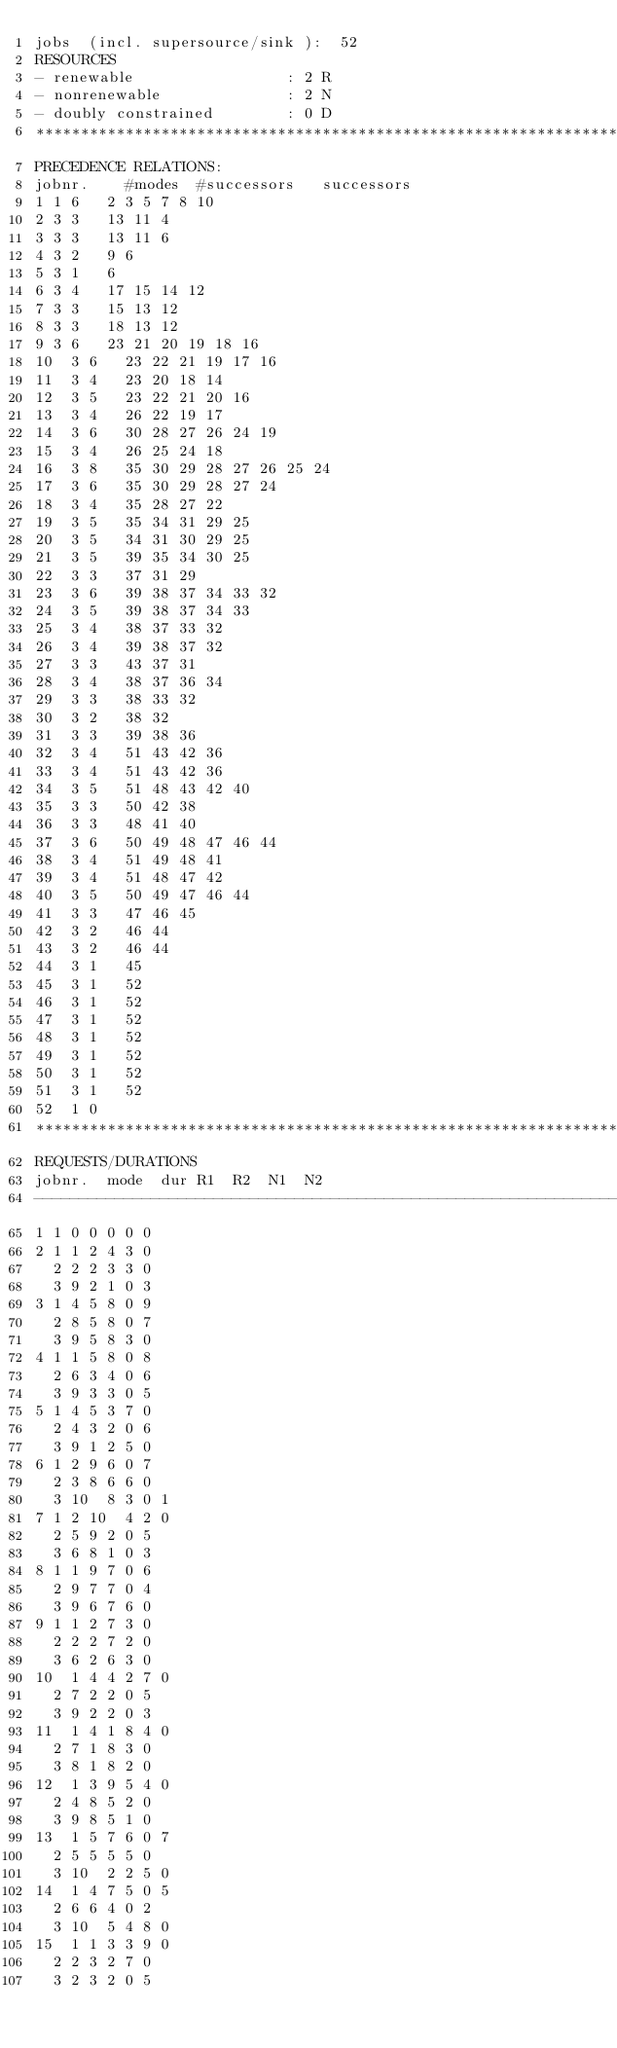<code> <loc_0><loc_0><loc_500><loc_500><_ObjectiveC_>jobs  (incl. supersource/sink ):	52
RESOURCES
- renewable                 : 2 R
- nonrenewable              : 2 N
- doubly constrained        : 0 D
************************************************************************
PRECEDENCE RELATIONS:
jobnr.    #modes  #successors   successors
1	1	6		2 3 5 7 8 10 
2	3	3		13 11 4 
3	3	3		13 11 6 
4	3	2		9 6 
5	3	1		6 
6	3	4		17 15 14 12 
7	3	3		15 13 12 
8	3	3		18 13 12 
9	3	6		23 21 20 19 18 16 
10	3	6		23 22 21 19 17 16 
11	3	4		23 20 18 14 
12	3	5		23 22 21 20 16 
13	3	4		26 22 19 17 
14	3	6		30 28 27 26 24 19 
15	3	4		26 25 24 18 
16	3	8		35 30 29 28 27 26 25 24 
17	3	6		35 30 29 28 27 24 
18	3	4		35 28 27 22 
19	3	5		35 34 31 29 25 
20	3	5		34 31 30 29 25 
21	3	5		39 35 34 30 25 
22	3	3		37 31 29 
23	3	6		39 38 37 34 33 32 
24	3	5		39 38 37 34 33 
25	3	4		38 37 33 32 
26	3	4		39 38 37 32 
27	3	3		43 37 31 
28	3	4		38 37 36 34 
29	3	3		38 33 32 
30	3	2		38 32 
31	3	3		39 38 36 
32	3	4		51 43 42 36 
33	3	4		51 43 42 36 
34	3	5		51 48 43 42 40 
35	3	3		50 42 38 
36	3	3		48 41 40 
37	3	6		50 49 48 47 46 44 
38	3	4		51 49 48 41 
39	3	4		51 48 47 42 
40	3	5		50 49 47 46 44 
41	3	3		47 46 45 
42	3	2		46 44 
43	3	2		46 44 
44	3	1		45 
45	3	1		52 
46	3	1		52 
47	3	1		52 
48	3	1		52 
49	3	1		52 
50	3	1		52 
51	3	1		52 
52	1	0		
************************************************************************
REQUESTS/DURATIONS
jobnr.	mode	dur	R1	R2	N1	N2	
------------------------------------------------------------------------
1	1	0	0	0	0	0	
2	1	1	2	4	3	0	
	2	2	2	3	3	0	
	3	9	2	1	0	3	
3	1	4	5	8	0	9	
	2	8	5	8	0	7	
	3	9	5	8	3	0	
4	1	1	5	8	0	8	
	2	6	3	4	0	6	
	3	9	3	3	0	5	
5	1	4	5	3	7	0	
	2	4	3	2	0	6	
	3	9	1	2	5	0	
6	1	2	9	6	0	7	
	2	3	8	6	6	0	
	3	10	8	3	0	1	
7	1	2	10	4	2	0	
	2	5	9	2	0	5	
	3	6	8	1	0	3	
8	1	1	9	7	0	6	
	2	9	7	7	0	4	
	3	9	6	7	6	0	
9	1	1	2	7	3	0	
	2	2	2	7	2	0	
	3	6	2	6	3	0	
10	1	4	4	2	7	0	
	2	7	2	2	0	5	
	3	9	2	2	0	3	
11	1	4	1	8	4	0	
	2	7	1	8	3	0	
	3	8	1	8	2	0	
12	1	3	9	5	4	0	
	2	4	8	5	2	0	
	3	9	8	5	1	0	
13	1	5	7	6	0	7	
	2	5	5	5	5	0	
	3	10	2	2	5	0	
14	1	4	7	5	0	5	
	2	6	6	4	0	2	
	3	10	5	4	8	0	
15	1	1	3	3	9	0	
	2	2	3	2	7	0	
	3	2	3	2	0	5	</code> 